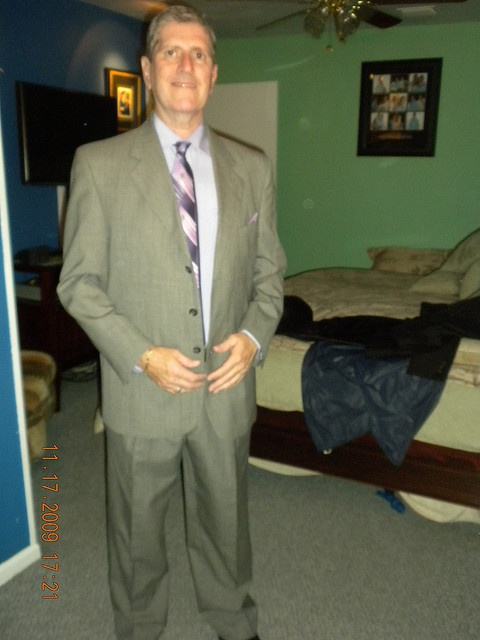Describe the objects in this image and their specific colors. I can see people in black, gray, darkgray, and darkgreen tones, bed in black, darkgreen, and olive tones, tv in black, gray, darkgreen, and maroon tones, and tie in black, lightgray, gray, darkgray, and pink tones in this image. 